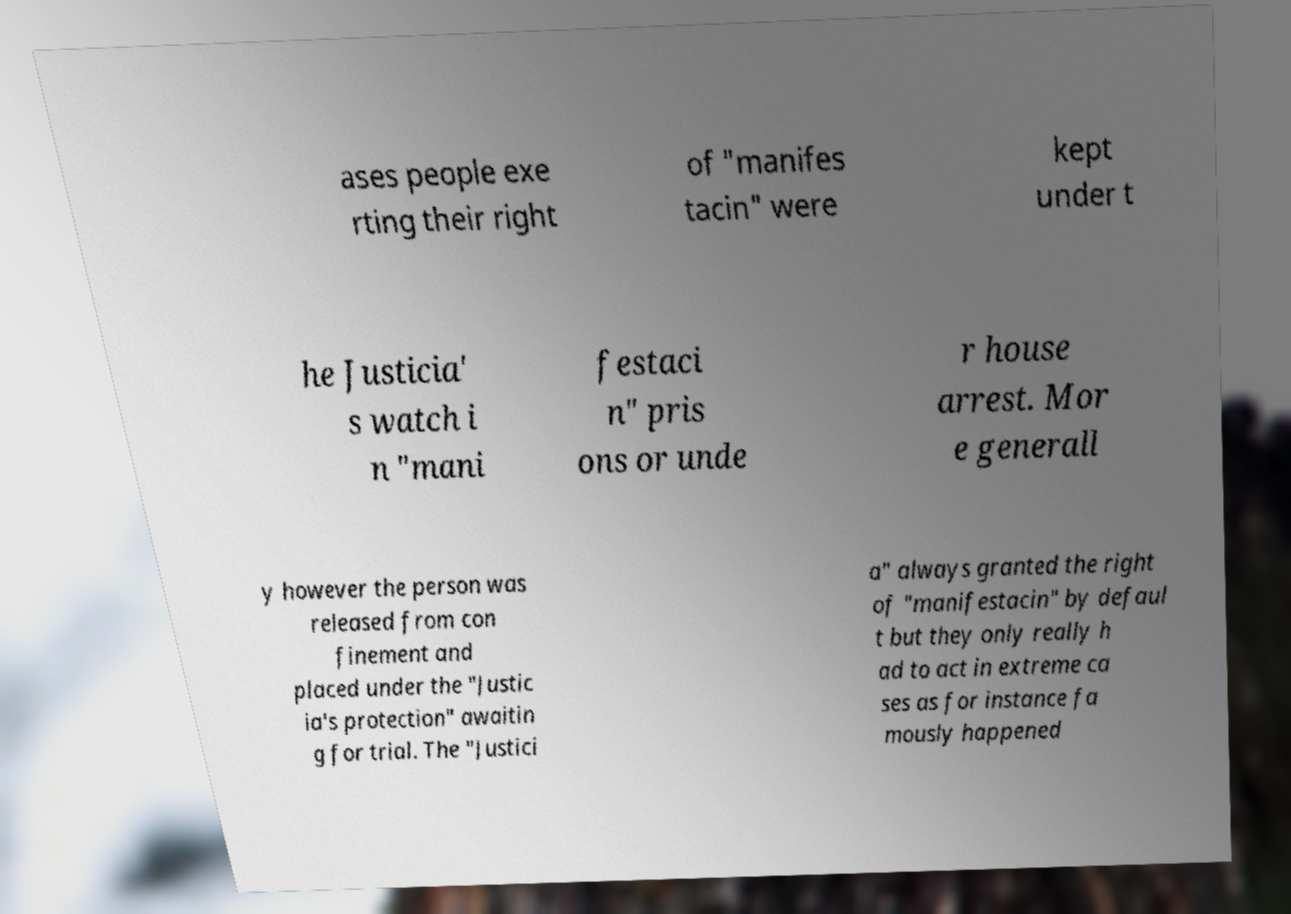What messages or text are displayed in this image? I need them in a readable, typed format. ases people exe rting their right of "manifes tacin" were kept under t he Justicia' s watch i n "mani festaci n" pris ons or unde r house arrest. Mor e generall y however the person was released from con finement and placed under the "Justic ia's protection" awaitin g for trial. The "Justici a" always granted the right of "manifestacin" by defaul t but they only really h ad to act in extreme ca ses as for instance fa mously happened 